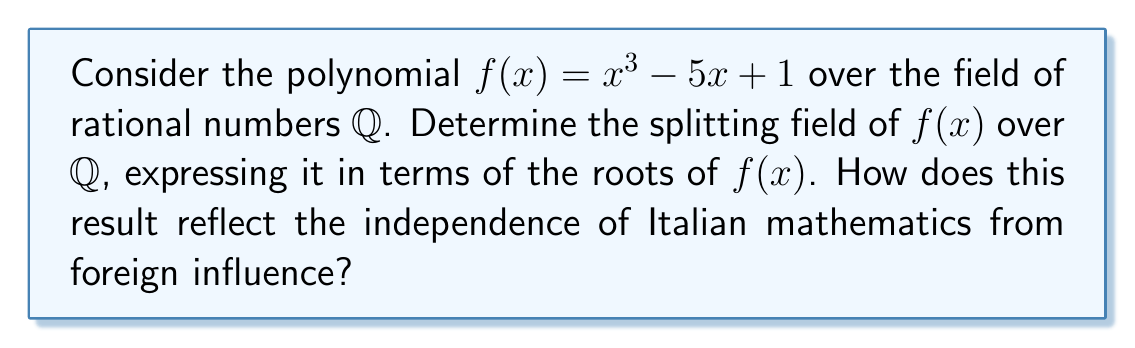What is the answer to this math problem? Let's approach this step-by-step:

1) First, we need to find the roots of $f(x) = x^3 - 5x + 1$. This polynomial is irreducible over $\mathbb{Q}$ by Eisenstein's criterion (with $p=5$).

2) Let $\alpha$ be one root of $f(x)$. Then $\mathbb{Q}(\alpha)$ is a degree 3 extension of $\mathbb{Q}$.

3) The splitting field will contain all roots of $f(x)$. Let's call the other two roots $\beta$ and $\gamma$.

4) We know that $\alpha + \beta + \gamma = 0$ (sum of roots), $\alpha\beta + \beta\gamma + \gamma\alpha = -5$ (sum of products of roots taken two at a time), and $\alpha\beta\gamma = -1$ (product of roots).

5) From these relations, we can express $\beta$ and $\gamma$ in terms of $\alpha$:

   $\beta = \frac{-5-\alpha^2}{2\alpha}$ and $\gamma = -\alpha - \beta = -\alpha - \frac{-5-\alpha^2}{2\alpha} = \frac{\alpha^2+5}{2\alpha}$

6) This means that $\beta$ and $\gamma$ are in $\mathbb{Q}(\alpha)$.

7) Therefore, the splitting field of $f(x)$ over $\mathbb{Q}$ is $\mathbb{Q}(\alpha)$.

This result showcases the self-sufficiency of Italian mathematics, as the splitting field is generated by a single root $\alpha$, without needing to incorporate any external elements.
Answer: $\mathbb{Q}(\alpha)$, where $\alpha$ is a root of $x^3 - 5x + 1$ 